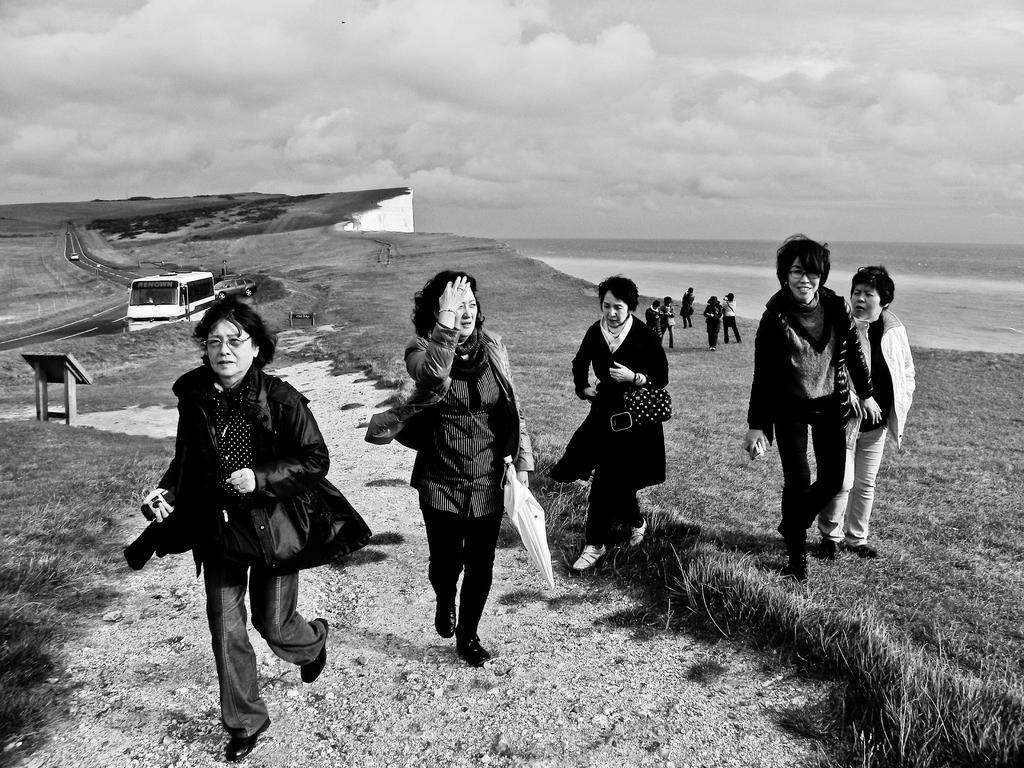In one or two sentences, can you explain what this image depicts? In front of the image there are a few people. Behind them there is a wooden table. There are vehicles on the road. At the bottom of the image there is grass on the surface. In the background of the image there is water. At the top of the image there are clouds in the sky. 